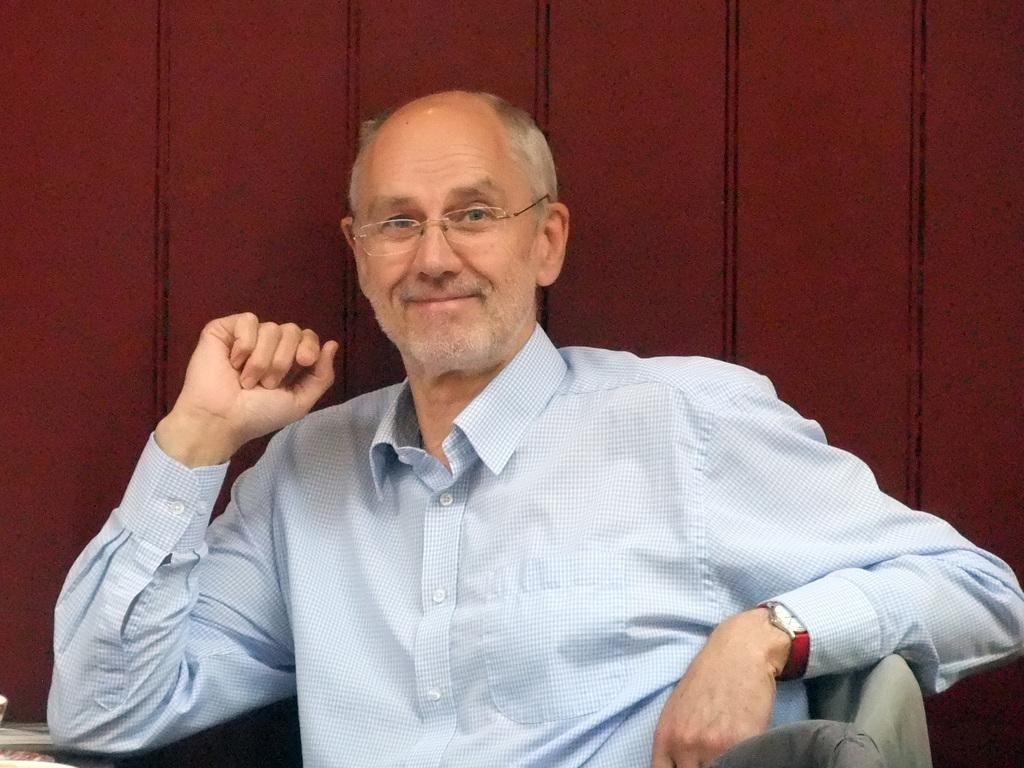What is the main subject of the image? There is a person in the image. What is the person wearing on their upper body? The person is wearing a white t-shirt. What accessory is the person wearing on their face? The person is wearing spectacles. What accessory is the person wearing on their wrist? The person is wearing a red watch. What is the person's facial expression in the image? The person is smiling. What color is the background of the image? The background of the image is brown. How many houses can be seen in the image? There are no houses present in the image; it features a person wearing a white t-shirt, spectacles, and a red watch, with a brown background. What type of bun is the person holding in the image? There is no bun present in the image. 